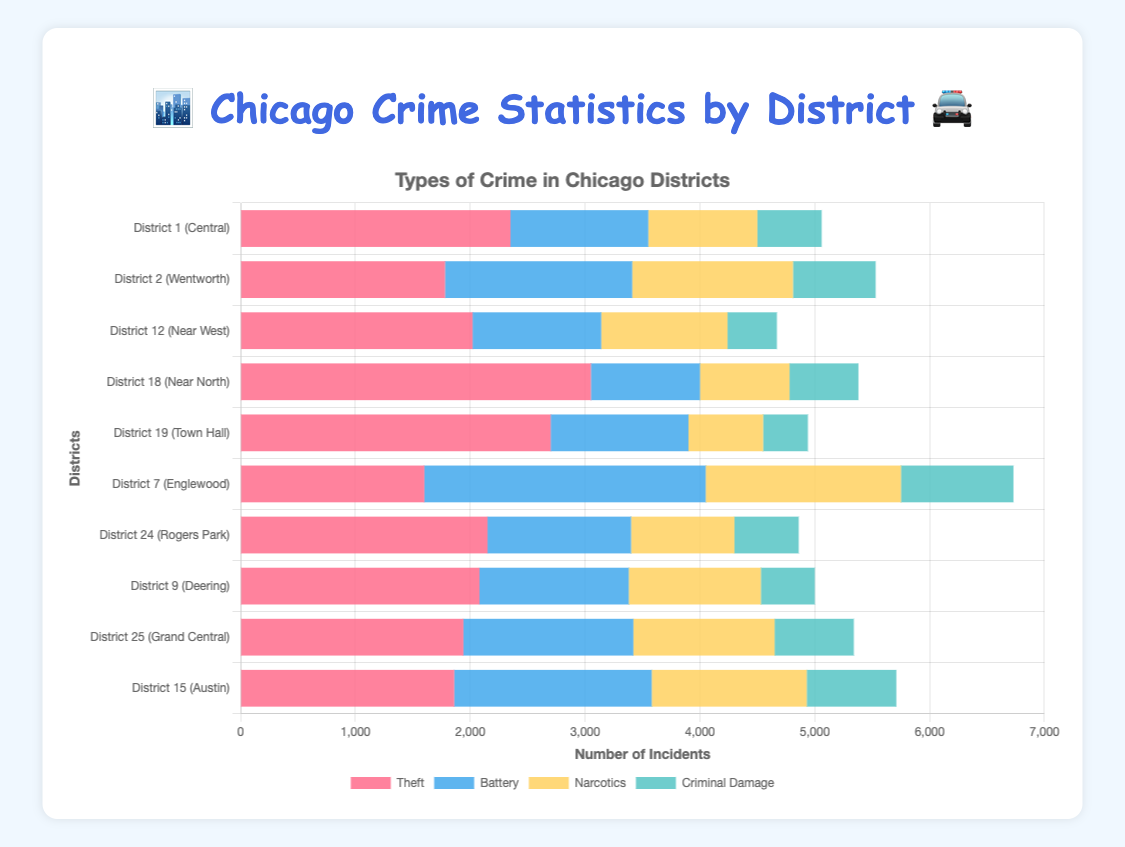Which district has the highest number of theft incidents? Observe the figure and locate the bar section for theft (red color). The bar with the longest length represents the highest number of incidents. District 18 (Near North) has the longest red bar for theft.
Answer: District 18 (Near North) Which crime is most prevalent in District 7 (Englewood)? Check the horizontal bars for District 7 and identify the bar segment with the greatest length. The battery bar (blue color) is the longest for District 7.
Answer: Battery What is the total number of crime incidents in District 1 (Central)? To find the total, sum up the values for each type of crime in District 1: Theft (2350) + Battery (1200) + Narcotics (950) + Criminal Damage (560).
Answer: 5060 In which district is narcotics crime least prevalent? Compare the lengths of the yellow narcotics bars across all districts. District 19 (Town Hall) has the shortest yellow bar for narcotics.
Answer: District 19 (Town Hall) How do the numbers of battery incidents in Districts 2 (Wentworth) and 15 (Austin) compare? Look at the lengths of the battery bars (blue color) for Districts 2 and 15. District 15 has a battery bar slightly longer than District 2.
Answer: District 15 (Austin) Which district has the smallest total number of criminal damage incidents? Locate the green bars representing criminal damage across all districts. District 19 (Town Hall) has the shortest green bar.
Answer: District 19 (Town Hall) What is the average number of narcotics incidents in the top three districts with the highest narcotics incidents? Identify the top three districts for narcotics (longest yellow bars): District 7 (1700), District 2 (1400), and District 15 (1350). Compute the average: (1700 + 1400 + 1350) / 3.
Answer: 1483.33 Is the number of theft incidents greater in District 24 (Rogers Park) or District 12 (Near West)? Compare the lengths of the theft bars (red) for Districts 24 and 12. District 24 has a longer red bar than District 12.
Answer: District 24 (Rogers Park) What is the combined number of battery and criminal damage incidents in District 25 (Grand Central)? Add the values for battery (1480) and criminal damage (690) in District 25: 1480 + 690.
Answer: 2170 How many total theft and narcotics incidents occur in the districts with the highest and lowest numbers for these categories? Identify District 18 for the highest theft (3050) and District 19 for the lowest narcotics (3050 + 650). For the highest narcotics (District 7, 1600) and lowest theft (District 7, 1700 with the lowest theft in District 7). Sum: 3050 (theft, District 18) + 650 (narcotics, District 19) + 1700 (narcotics, District 7) + 1600 (narcotics, District 2 (650) and lowest theft).
Answer: 6650 